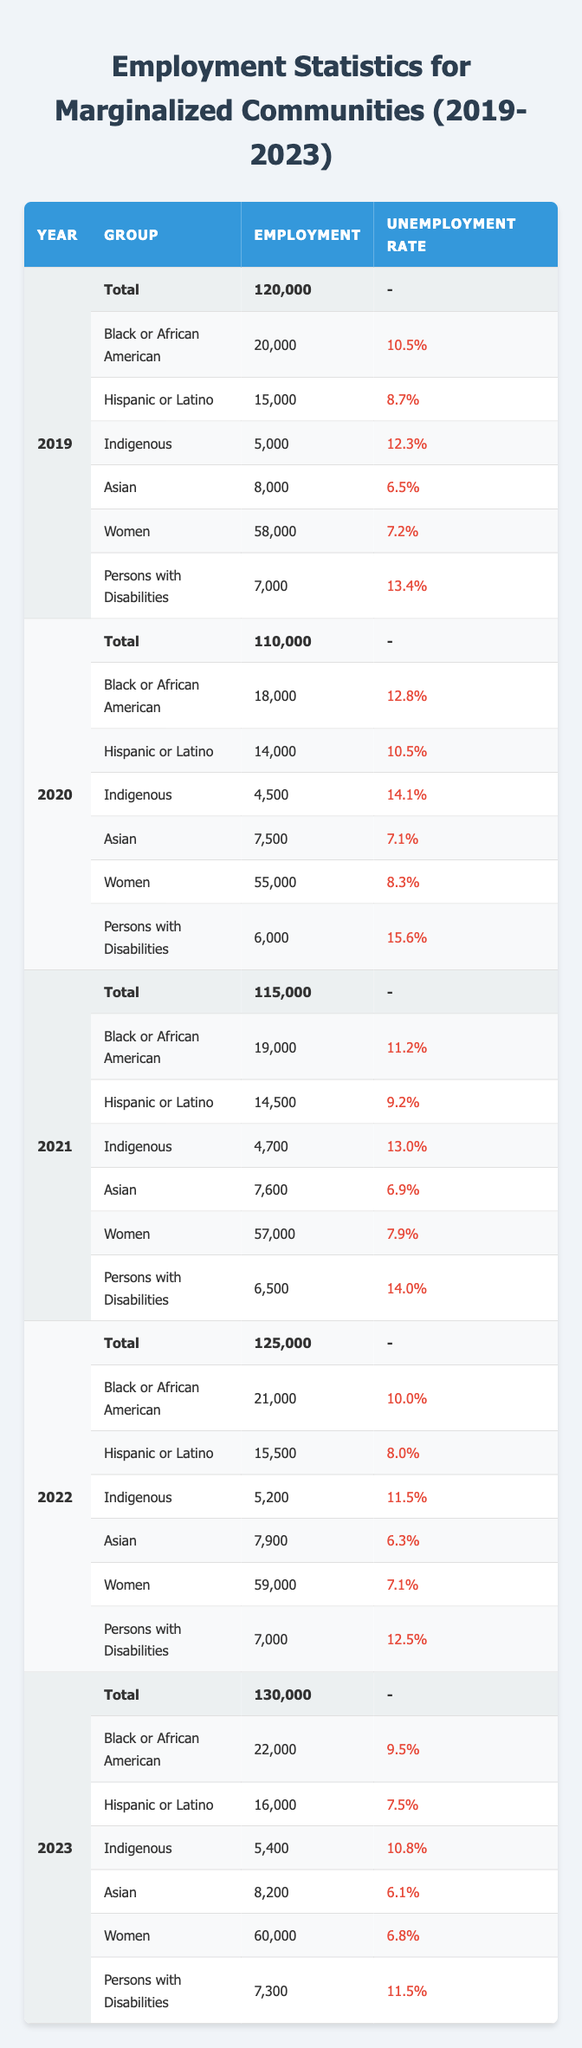What was the total employment in 2023? The table shows a total employment value under the row for the year 2023, which is directly listed as 130,000.
Answer: 130,000 Which group had the highest unemployment rate in 2020? By looking at the unemployment rates for all groups in 2020, "Persons with Disabilities" had the highest rate at 15.6%.
Answer: 15.6% What is the difference in employment numbers for Black or African American individuals between 2021 and 2023? In 2021, the employment number for Black or African American individuals was 19,000, and in 2023, it was 22,000. Subtracting the two gives us 22,000 - 19,000 = 3,000.
Answer: 3,000 How many more Hispanic or Latino individuals were employed in 2022 compared to 2019? The employment for Hispanic or Latino individuals in 2019 was 15,000 and in 2022 it was 15,500. The difference is 15,500 - 15,000 = 500.
Answer: 500 Did the employment for women in 2022 surpass 56,000? The table shows that the employment number for women in 2022 is 59,000, which is greater than 56,000.
Answer: Yes What was the average unemployment rate for Indigenous individuals over the five years? The unemployment rates for Indigenous individuals across the years are: 12.3%, 14.1%, 13.0%, 11.5%, and 10.8%. Summing these gives 12.3 + 14.1 + 13.0 + 11.5 + 10.8 = 61.7. Dividing by 5 gives the average: 61.7 / 5 = 12.34.
Answer: 12.34 Which group showed the most improvement in unemployment rate from 2020 to 2023? For this, we compare the unemployment rates of each group from 2020 to 2023. The rates for Black or African American individuals dropped from 12.8% to 9.5%, a difference of 3.3%. Other groups also showed improvements, but this specific rate shows a significant drop.
Answer: Black or African American Was the total employment in 2021 lower than the total employment in 2019? In 2021, the total employment is 115,000, and in 2019, it is 120,000. Since 115,000 is less than 120,000, the statement is true.
Answer: Yes What is the trend of total employment from 2019 to 2023? By examining the total employment numbers, we see they increased from 120,000 in 2019 to 130,000 in 2023, showing a steady rise of 10,000 each year.
Answer: Steady increase 